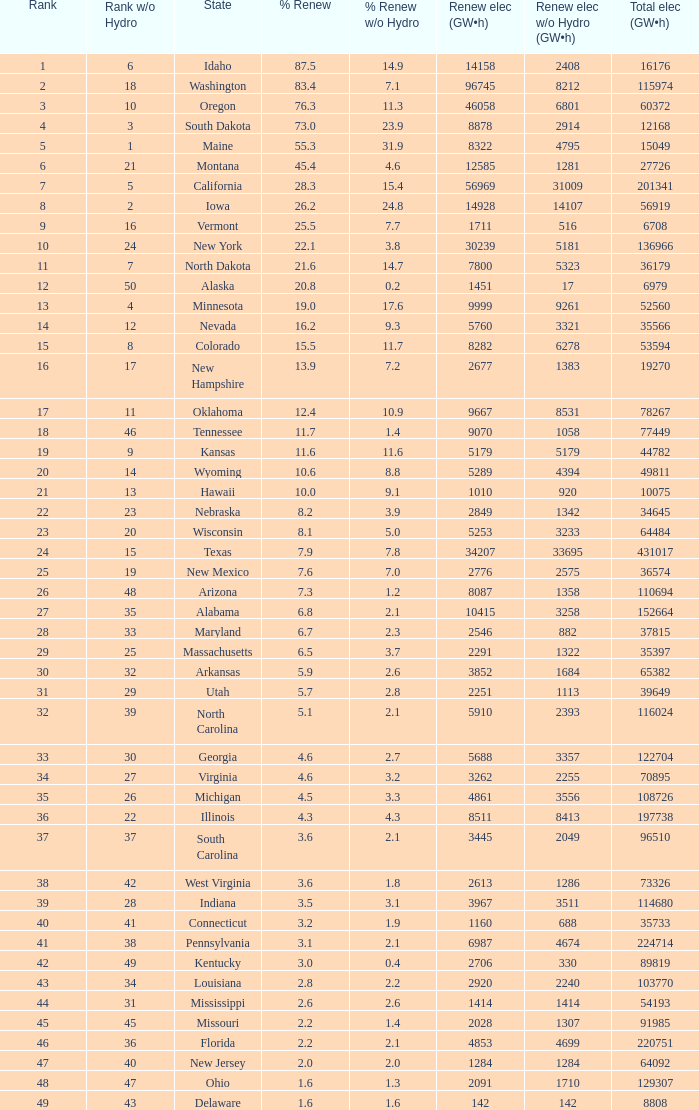What is the utmost renewable energy (gw×h) for the state of delaware? 142.0. 